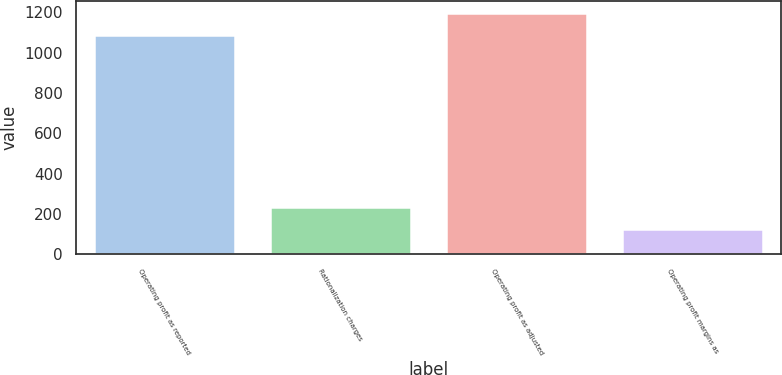<chart> <loc_0><loc_0><loc_500><loc_500><bar_chart><fcel>Operating profit as reported<fcel>Rationalization charges<fcel>Operating profit as adjusted<fcel>Operating profit margins as<nl><fcel>1087<fcel>233.64<fcel>1196.42<fcel>124.22<nl></chart> 